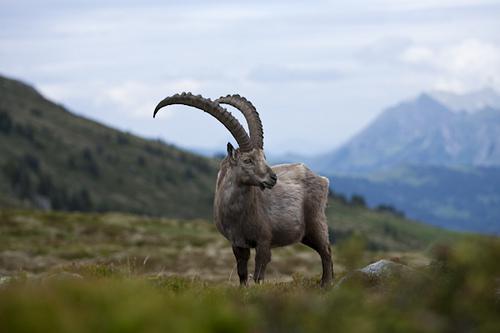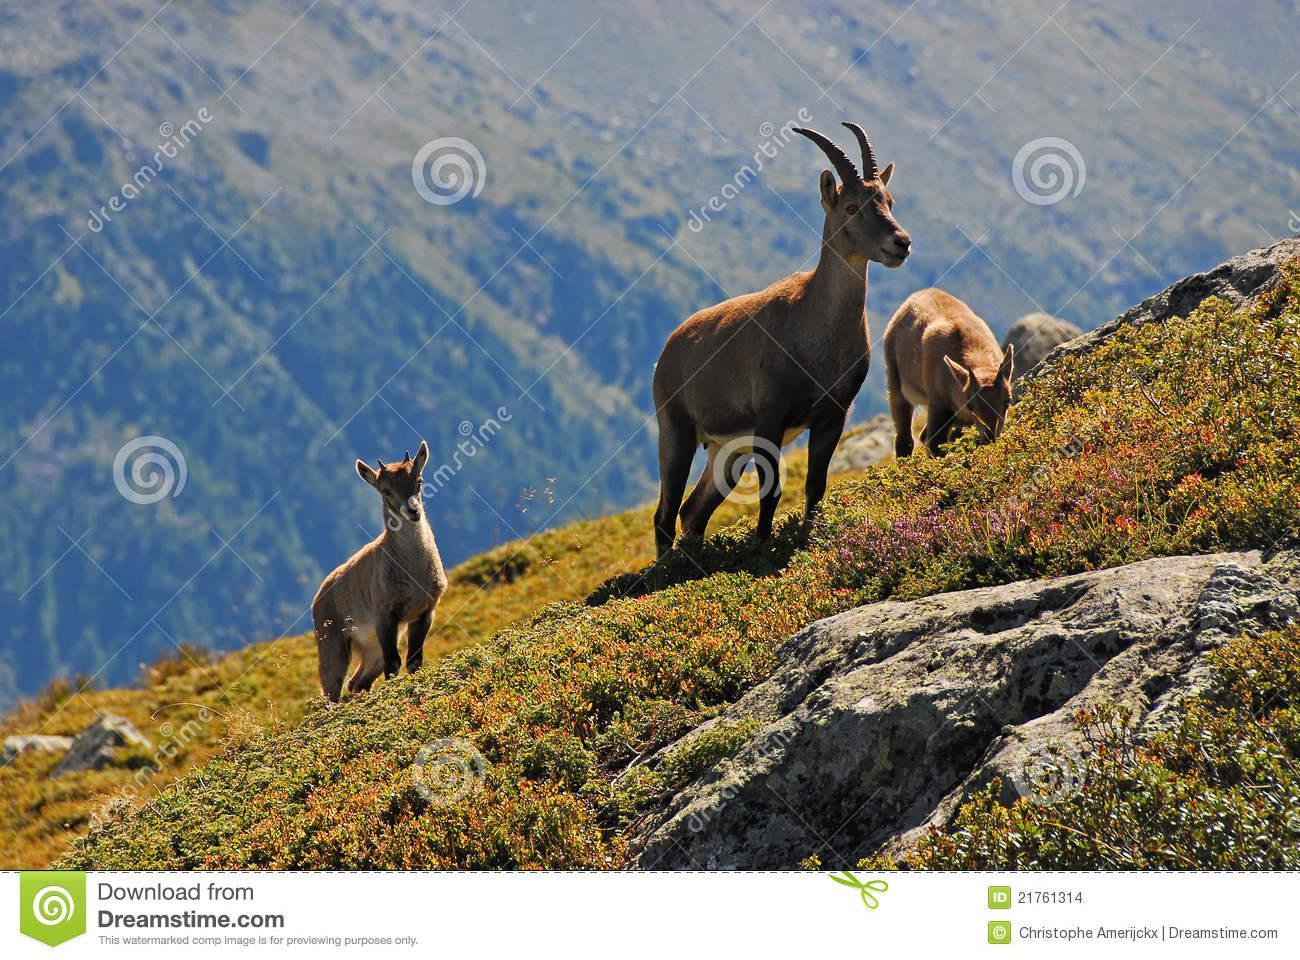The first image is the image on the left, the second image is the image on the right. For the images displayed, is the sentence "An image shows exactly one long-horned animal, which is posed with legs tucked underneath." factually correct? Answer yes or no. No. The first image is the image on the left, the second image is the image on the right. Examine the images to the left and right. Is the description "One of the images shows a horned mountain goat laying in the grass with mountains behind it." accurate? Answer yes or no. No. 